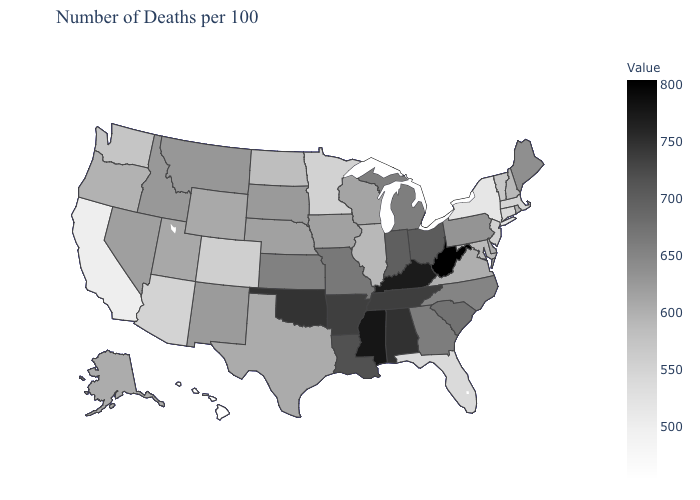Does Illinois have the highest value in the MidWest?
Answer briefly. No. Does Hawaii have the lowest value in the West?
Concise answer only. Yes. Does Nebraska have a higher value than Alabama?
Short answer required. No. Does Maryland have a higher value than Montana?
Quick response, please. No. Does Kentucky have the highest value in the USA?
Keep it brief. No. 